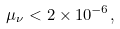<formula> <loc_0><loc_0><loc_500><loc_500>\mu _ { \nu } < 2 \times 1 0 ^ { - 6 } ,</formula> 